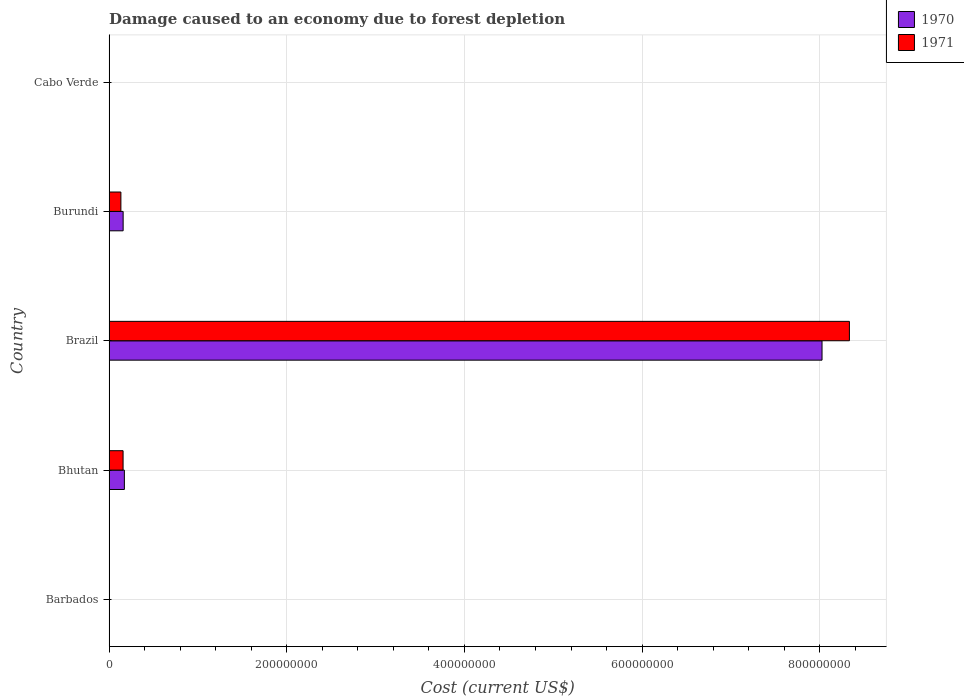How many groups of bars are there?
Your answer should be very brief. 5. How many bars are there on the 3rd tick from the top?
Your answer should be compact. 2. What is the label of the 5th group of bars from the top?
Your answer should be very brief. Barbados. In how many cases, is the number of bars for a given country not equal to the number of legend labels?
Offer a very short reply. 0. What is the cost of damage caused due to forest depletion in 1971 in Brazil?
Make the answer very short. 8.33e+08. Across all countries, what is the maximum cost of damage caused due to forest depletion in 1970?
Give a very brief answer. 8.03e+08. Across all countries, what is the minimum cost of damage caused due to forest depletion in 1970?
Offer a terse response. 3.70e+04. In which country was the cost of damage caused due to forest depletion in 1971 minimum?
Offer a very short reply. Barbados. What is the total cost of damage caused due to forest depletion in 1971 in the graph?
Provide a short and direct response. 8.63e+08. What is the difference between the cost of damage caused due to forest depletion in 1971 in Barbados and that in Bhutan?
Provide a short and direct response. -1.57e+07. What is the difference between the cost of damage caused due to forest depletion in 1971 in Bhutan and the cost of damage caused due to forest depletion in 1970 in Barbados?
Provide a succinct answer. 1.57e+07. What is the average cost of damage caused due to forest depletion in 1970 per country?
Your answer should be very brief. 1.67e+08. What is the difference between the cost of damage caused due to forest depletion in 1971 and cost of damage caused due to forest depletion in 1970 in Burundi?
Your answer should be very brief. -2.54e+06. In how many countries, is the cost of damage caused due to forest depletion in 1970 greater than 120000000 US$?
Offer a very short reply. 1. What is the ratio of the cost of damage caused due to forest depletion in 1970 in Brazil to that in Burundi?
Offer a very short reply. 50.66. What is the difference between the highest and the second highest cost of damage caused due to forest depletion in 1970?
Ensure brevity in your answer.  7.85e+08. What is the difference between the highest and the lowest cost of damage caused due to forest depletion in 1971?
Provide a succinct answer. 8.33e+08. Is the sum of the cost of damage caused due to forest depletion in 1971 in Barbados and Burundi greater than the maximum cost of damage caused due to forest depletion in 1970 across all countries?
Your answer should be compact. No. What does the 1st bar from the bottom in Brazil represents?
Offer a very short reply. 1970. How many bars are there?
Provide a short and direct response. 10. Are all the bars in the graph horizontal?
Your response must be concise. Yes. Are the values on the major ticks of X-axis written in scientific E-notation?
Your response must be concise. No. Does the graph contain grids?
Your answer should be compact. Yes. How many legend labels are there?
Provide a succinct answer. 2. What is the title of the graph?
Ensure brevity in your answer.  Damage caused to an economy due to forest depletion. What is the label or title of the X-axis?
Your answer should be compact. Cost (current US$). What is the Cost (current US$) in 1970 in Barbados?
Offer a very short reply. 3.70e+04. What is the Cost (current US$) of 1971 in Barbados?
Make the answer very short. 2.86e+04. What is the Cost (current US$) in 1970 in Bhutan?
Make the answer very short. 1.72e+07. What is the Cost (current US$) of 1971 in Bhutan?
Offer a terse response. 1.58e+07. What is the Cost (current US$) in 1970 in Brazil?
Your answer should be very brief. 8.03e+08. What is the Cost (current US$) of 1971 in Brazil?
Offer a terse response. 8.33e+08. What is the Cost (current US$) in 1970 in Burundi?
Your response must be concise. 1.58e+07. What is the Cost (current US$) of 1971 in Burundi?
Give a very brief answer. 1.33e+07. What is the Cost (current US$) in 1970 in Cabo Verde?
Give a very brief answer. 2.02e+05. What is the Cost (current US$) in 1971 in Cabo Verde?
Ensure brevity in your answer.  1.81e+05. Across all countries, what is the maximum Cost (current US$) in 1970?
Your response must be concise. 8.03e+08. Across all countries, what is the maximum Cost (current US$) in 1971?
Your answer should be compact. 8.33e+08. Across all countries, what is the minimum Cost (current US$) in 1970?
Provide a short and direct response. 3.70e+04. Across all countries, what is the minimum Cost (current US$) of 1971?
Offer a terse response. 2.86e+04. What is the total Cost (current US$) in 1970 in the graph?
Offer a terse response. 8.36e+08. What is the total Cost (current US$) in 1971 in the graph?
Your answer should be very brief. 8.63e+08. What is the difference between the Cost (current US$) in 1970 in Barbados and that in Bhutan?
Provide a succinct answer. -1.72e+07. What is the difference between the Cost (current US$) of 1971 in Barbados and that in Bhutan?
Ensure brevity in your answer.  -1.57e+07. What is the difference between the Cost (current US$) of 1970 in Barbados and that in Brazil?
Offer a very short reply. -8.03e+08. What is the difference between the Cost (current US$) in 1971 in Barbados and that in Brazil?
Make the answer very short. -8.33e+08. What is the difference between the Cost (current US$) in 1970 in Barbados and that in Burundi?
Your response must be concise. -1.58e+07. What is the difference between the Cost (current US$) in 1971 in Barbados and that in Burundi?
Give a very brief answer. -1.33e+07. What is the difference between the Cost (current US$) of 1970 in Barbados and that in Cabo Verde?
Make the answer very short. -1.65e+05. What is the difference between the Cost (current US$) in 1971 in Barbados and that in Cabo Verde?
Your response must be concise. -1.52e+05. What is the difference between the Cost (current US$) in 1970 in Bhutan and that in Brazil?
Your answer should be compact. -7.85e+08. What is the difference between the Cost (current US$) in 1971 in Bhutan and that in Brazil?
Make the answer very short. -8.18e+08. What is the difference between the Cost (current US$) in 1970 in Bhutan and that in Burundi?
Give a very brief answer. 1.40e+06. What is the difference between the Cost (current US$) of 1971 in Bhutan and that in Burundi?
Keep it short and to the point. 2.47e+06. What is the difference between the Cost (current US$) of 1970 in Bhutan and that in Cabo Verde?
Ensure brevity in your answer.  1.70e+07. What is the difference between the Cost (current US$) of 1971 in Bhutan and that in Cabo Verde?
Provide a succinct answer. 1.56e+07. What is the difference between the Cost (current US$) of 1970 in Brazil and that in Burundi?
Ensure brevity in your answer.  7.87e+08. What is the difference between the Cost (current US$) of 1971 in Brazil and that in Burundi?
Provide a succinct answer. 8.20e+08. What is the difference between the Cost (current US$) in 1970 in Brazil and that in Cabo Verde?
Offer a very short reply. 8.02e+08. What is the difference between the Cost (current US$) of 1971 in Brazil and that in Cabo Verde?
Your answer should be compact. 8.33e+08. What is the difference between the Cost (current US$) of 1970 in Burundi and that in Cabo Verde?
Give a very brief answer. 1.56e+07. What is the difference between the Cost (current US$) in 1971 in Burundi and that in Cabo Verde?
Offer a terse response. 1.31e+07. What is the difference between the Cost (current US$) in 1970 in Barbados and the Cost (current US$) in 1971 in Bhutan?
Ensure brevity in your answer.  -1.57e+07. What is the difference between the Cost (current US$) in 1970 in Barbados and the Cost (current US$) in 1971 in Brazil?
Make the answer very short. -8.33e+08. What is the difference between the Cost (current US$) of 1970 in Barbados and the Cost (current US$) of 1971 in Burundi?
Your answer should be compact. -1.33e+07. What is the difference between the Cost (current US$) in 1970 in Barbados and the Cost (current US$) in 1971 in Cabo Verde?
Offer a very short reply. -1.44e+05. What is the difference between the Cost (current US$) in 1970 in Bhutan and the Cost (current US$) in 1971 in Brazil?
Provide a short and direct response. -8.16e+08. What is the difference between the Cost (current US$) in 1970 in Bhutan and the Cost (current US$) in 1971 in Burundi?
Provide a succinct answer. 3.94e+06. What is the difference between the Cost (current US$) of 1970 in Bhutan and the Cost (current US$) of 1971 in Cabo Verde?
Ensure brevity in your answer.  1.71e+07. What is the difference between the Cost (current US$) of 1970 in Brazil and the Cost (current US$) of 1971 in Burundi?
Offer a terse response. 7.89e+08. What is the difference between the Cost (current US$) in 1970 in Brazil and the Cost (current US$) in 1971 in Cabo Verde?
Offer a very short reply. 8.02e+08. What is the difference between the Cost (current US$) of 1970 in Burundi and the Cost (current US$) of 1971 in Cabo Verde?
Ensure brevity in your answer.  1.57e+07. What is the average Cost (current US$) in 1970 per country?
Offer a terse response. 1.67e+08. What is the average Cost (current US$) in 1971 per country?
Offer a very short reply. 1.73e+08. What is the difference between the Cost (current US$) in 1970 and Cost (current US$) in 1971 in Barbados?
Your answer should be compact. 8397.63. What is the difference between the Cost (current US$) in 1970 and Cost (current US$) in 1971 in Bhutan?
Offer a very short reply. 1.47e+06. What is the difference between the Cost (current US$) of 1970 and Cost (current US$) of 1971 in Brazil?
Your response must be concise. -3.08e+07. What is the difference between the Cost (current US$) in 1970 and Cost (current US$) in 1971 in Burundi?
Your answer should be very brief. 2.54e+06. What is the difference between the Cost (current US$) of 1970 and Cost (current US$) of 1971 in Cabo Verde?
Give a very brief answer. 2.17e+04. What is the ratio of the Cost (current US$) of 1970 in Barbados to that in Bhutan?
Your answer should be compact. 0. What is the ratio of the Cost (current US$) of 1971 in Barbados to that in Bhutan?
Your answer should be compact. 0. What is the ratio of the Cost (current US$) of 1970 in Barbados to that in Brazil?
Ensure brevity in your answer.  0. What is the ratio of the Cost (current US$) in 1971 in Barbados to that in Brazil?
Your answer should be very brief. 0. What is the ratio of the Cost (current US$) of 1970 in Barbados to that in Burundi?
Your response must be concise. 0. What is the ratio of the Cost (current US$) of 1971 in Barbados to that in Burundi?
Offer a terse response. 0. What is the ratio of the Cost (current US$) in 1970 in Barbados to that in Cabo Verde?
Provide a succinct answer. 0.18. What is the ratio of the Cost (current US$) of 1971 in Barbados to that in Cabo Verde?
Make the answer very short. 0.16. What is the ratio of the Cost (current US$) in 1970 in Bhutan to that in Brazil?
Make the answer very short. 0.02. What is the ratio of the Cost (current US$) in 1971 in Bhutan to that in Brazil?
Your answer should be compact. 0.02. What is the ratio of the Cost (current US$) of 1970 in Bhutan to that in Burundi?
Provide a short and direct response. 1.09. What is the ratio of the Cost (current US$) of 1971 in Bhutan to that in Burundi?
Your answer should be very brief. 1.19. What is the ratio of the Cost (current US$) of 1970 in Bhutan to that in Cabo Verde?
Keep it short and to the point. 85.14. What is the ratio of the Cost (current US$) of 1971 in Bhutan to that in Cabo Verde?
Make the answer very short. 87.25. What is the ratio of the Cost (current US$) of 1970 in Brazil to that in Burundi?
Your response must be concise. 50.66. What is the ratio of the Cost (current US$) of 1971 in Brazil to that in Burundi?
Make the answer very short. 62.65. What is the ratio of the Cost (current US$) of 1970 in Brazil to that in Cabo Verde?
Offer a terse response. 3963.48. What is the ratio of the Cost (current US$) of 1971 in Brazil to that in Cabo Verde?
Your answer should be very brief. 4609.27. What is the ratio of the Cost (current US$) in 1970 in Burundi to that in Cabo Verde?
Keep it short and to the point. 78.23. What is the ratio of the Cost (current US$) of 1971 in Burundi to that in Cabo Verde?
Keep it short and to the point. 73.58. What is the difference between the highest and the second highest Cost (current US$) of 1970?
Ensure brevity in your answer.  7.85e+08. What is the difference between the highest and the second highest Cost (current US$) in 1971?
Keep it short and to the point. 8.18e+08. What is the difference between the highest and the lowest Cost (current US$) in 1970?
Your answer should be compact. 8.03e+08. What is the difference between the highest and the lowest Cost (current US$) of 1971?
Give a very brief answer. 8.33e+08. 